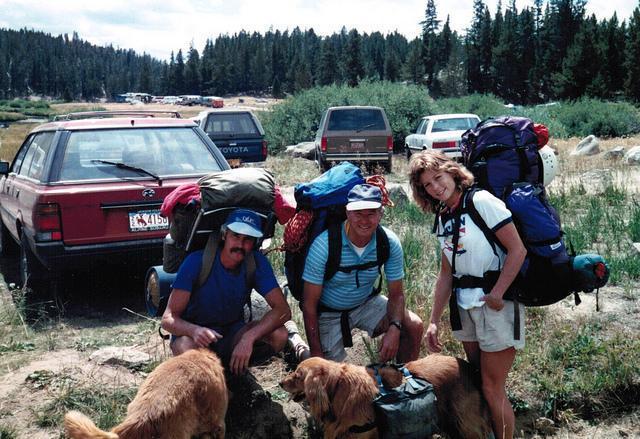How many cars are there?
Give a very brief answer. 4. How many dogs are there?
Give a very brief answer. 2. How many backpacks are in the photo?
Give a very brief answer. 4. How many people can be seen?
Give a very brief answer. 3. How many spoons are on the table?
Give a very brief answer. 0. 